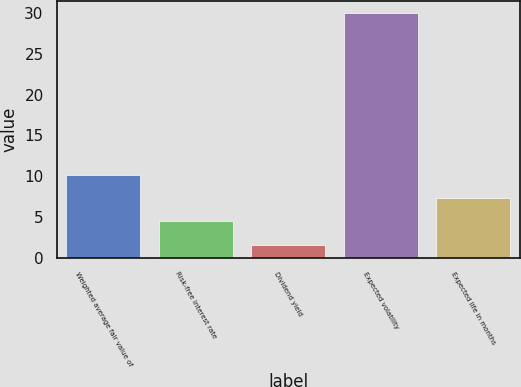Convert chart to OTSL. <chart><loc_0><loc_0><loc_500><loc_500><bar_chart><fcel>Weighted average fair value of<fcel>Risk-free interest rate<fcel>Dividend yield<fcel>Expected volatility<fcel>Expected life in months<nl><fcel>10.12<fcel>4.44<fcel>1.6<fcel>30<fcel>7.28<nl></chart> 